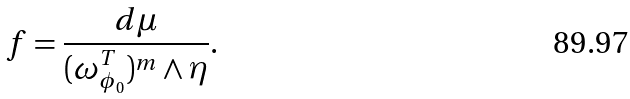Convert formula to latex. <formula><loc_0><loc_0><loc_500><loc_500>f = \frac { d \mu } { ( \omega ^ { T } _ { \phi _ { 0 } } ) ^ { m } \wedge \eta } .</formula> 